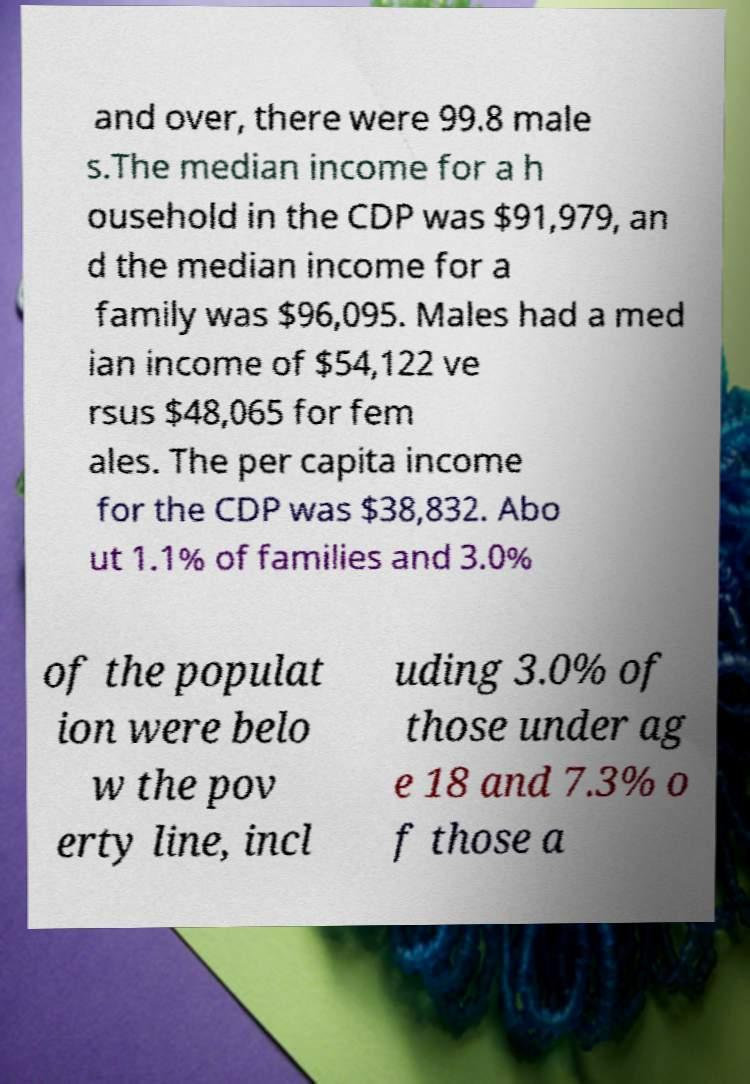Could you assist in decoding the text presented in this image and type it out clearly? and over, there were 99.8 male s.The median income for a h ousehold in the CDP was $91,979, an d the median income for a family was $96,095. Males had a med ian income of $54,122 ve rsus $48,065 for fem ales. The per capita income for the CDP was $38,832. Abo ut 1.1% of families and 3.0% of the populat ion were belo w the pov erty line, incl uding 3.0% of those under ag e 18 and 7.3% o f those a 